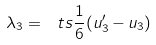<formula> <loc_0><loc_0><loc_500><loc_500>\lambda _ { 3 } = { \ t s \frac { 1 } { 6 } } ( u ^ { \prime } _ { 3 } - u _ { 3 } )</formula> 